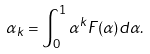Convert formula to latex. <formula><loc_0><loc_0><loc_500><loc_500>\alpha _ { k } = \int _ { 0 } ^ { 1 } \alpha ^ { k } F ( \alpha ) d \alpha .</formula> 